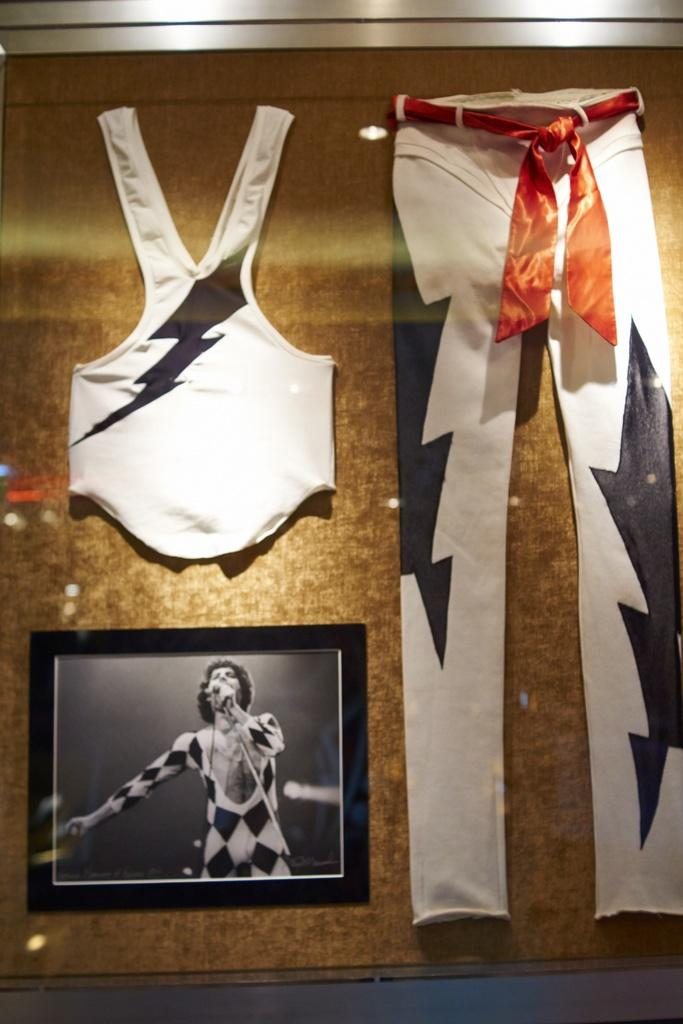What is the color of the main object in the image? The main object in the image is golden-colored. What is placed on the golden object? There are two white-colored clothes and a black and white frame on the golden object. What type of pets can be seen in the image? There are no pets visible in the image. What is the caption written on the golden object? There is no caption written on the golden object in the image. 